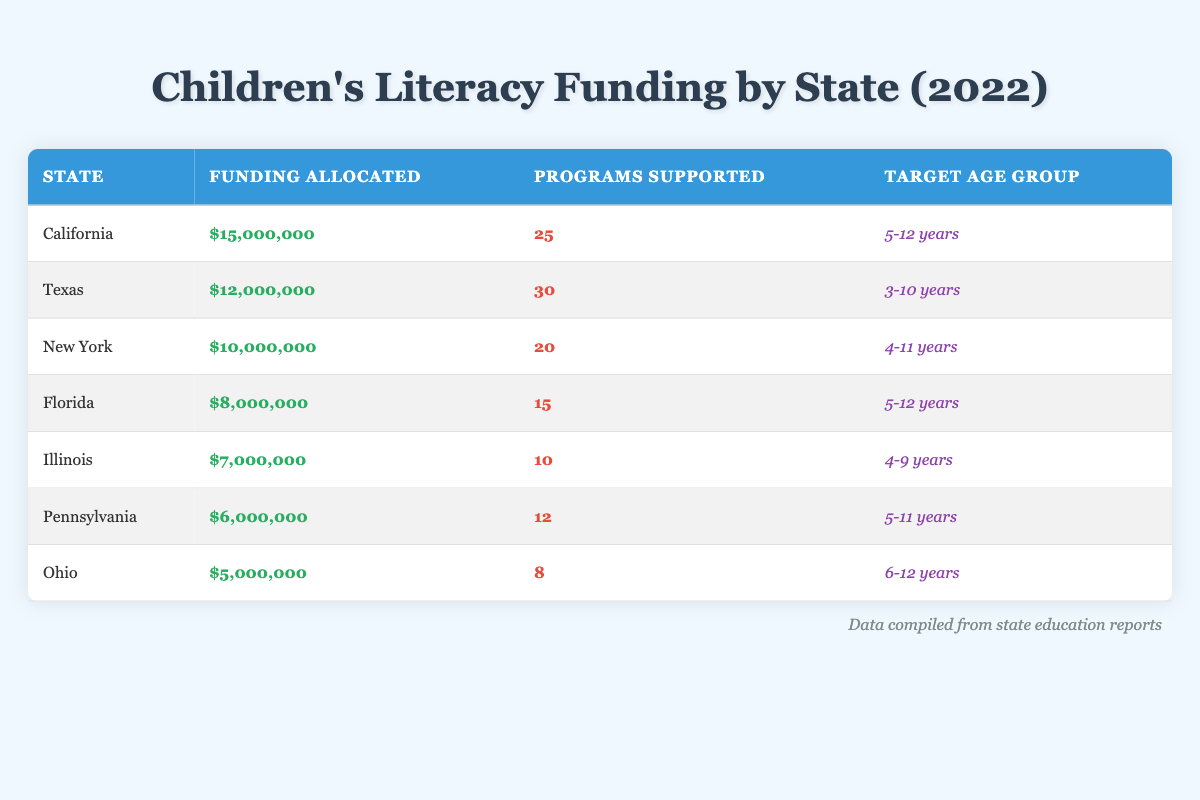What state allocated the highest funding for children's literacy programs in 2022? By examining the funding allocated for each state, I can see that California has the highest amount at $15,000,000.
Answer: California How many programs were supported in New York? The table indicates that New York supported a total of 20 programs for children's literacy in 2022.
Answer: 20 What is the total funding allocated by Florida and Illinois? To find the total funding, I add Florida's allocation of $8,000,000 to Illinois's allocation of $7,000,000, which gives us $15,000,000 total.
Answer: 15000000 Is it true that Ohio supported more programs than Pennsylvania? Checking the table, Ohio supported 8 programs while Pennsylvania supported 12 programs, thus, it is false that Ohio supported more programs.
Answer: No What is the average funding allocated per program for Texas? To find the average funding per program, I divide Texas's total funding of $12,000,000 by the number of programs supported, which is 30. The result is $400,000 per program ($12,000,000 / 30 = $400,000).
Answer: 400000 Which state had the lowest funding allocated, and what was the amount? Comparing all the funding amounts, Ohio had the lowest funding allocated, which is $5,000,000.
Answer: Ohio, 5000000 How many states supported programs targeting the age group of 5-12 years? The states targeting the age group of 5-12 years are California and Florida. Thus, there are 2 states in total.
Answer: 2 What is the difference in funding between Texas and New York? Calculating the difference, Texas received $12,000,000 and New York received $10,000,000. Therefore, the difference is $2,000,000 ($12,000,000 - $10,000,000).
Answer: 2000000 Did any state support more than 30 programs? Upon reviewing the table, Texas supported 30 programs but no state exceeded this number, making the statement false.
Answer: No 